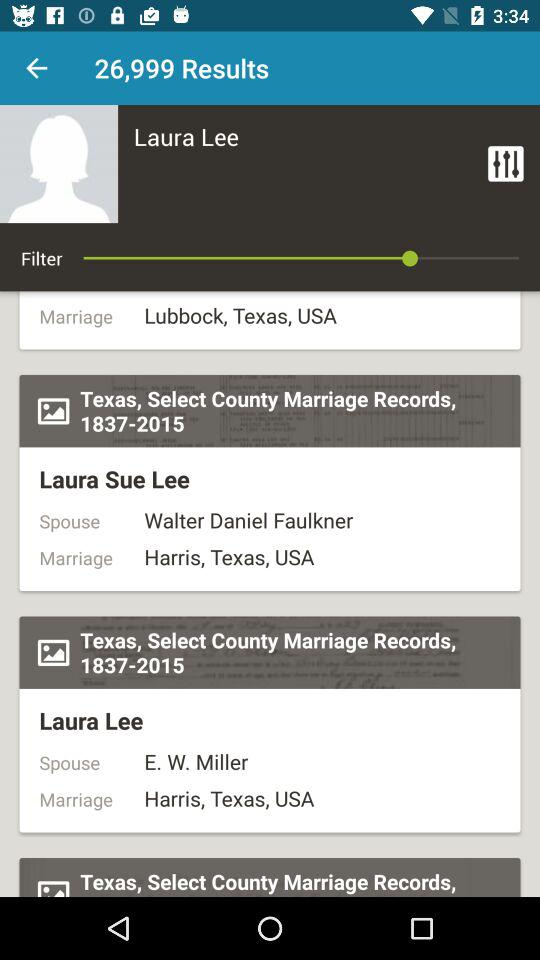What is the spouse's name of Laura Sue Lee? The spouse's name of Laura Sue Lee is Walter Daniel Faulkner. 